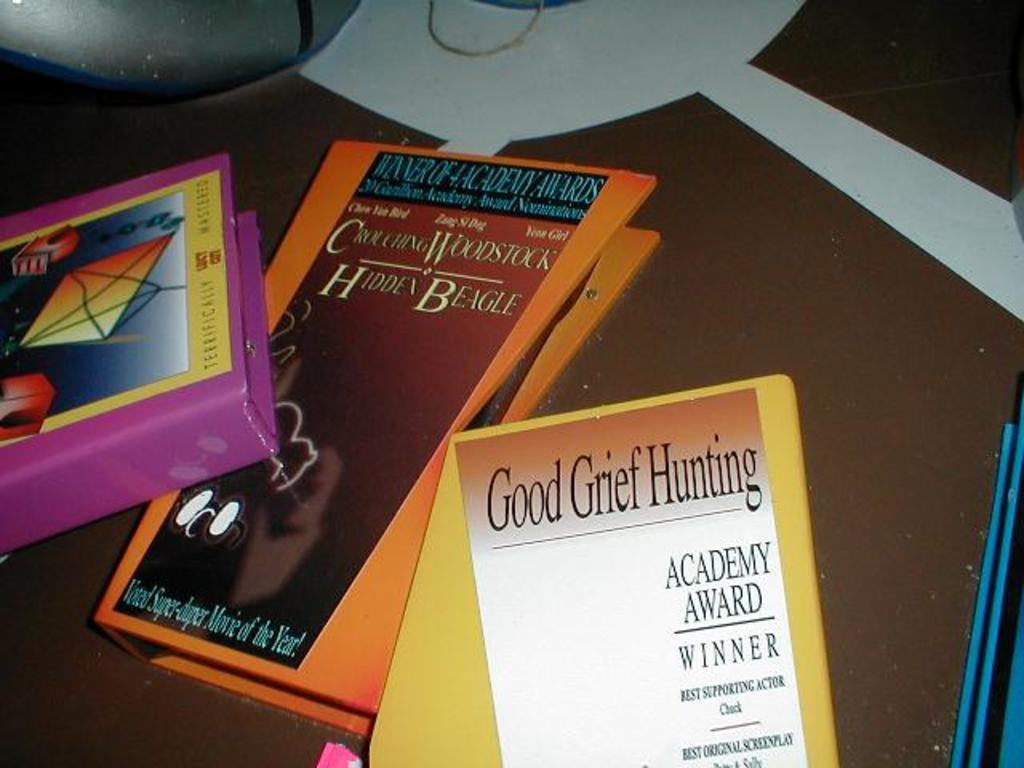What are the titles of these books?
Your answer should be compact. Good grief hunting. Which book was from academy award winner?
Provide a succinct answer. Good grief hunting. 